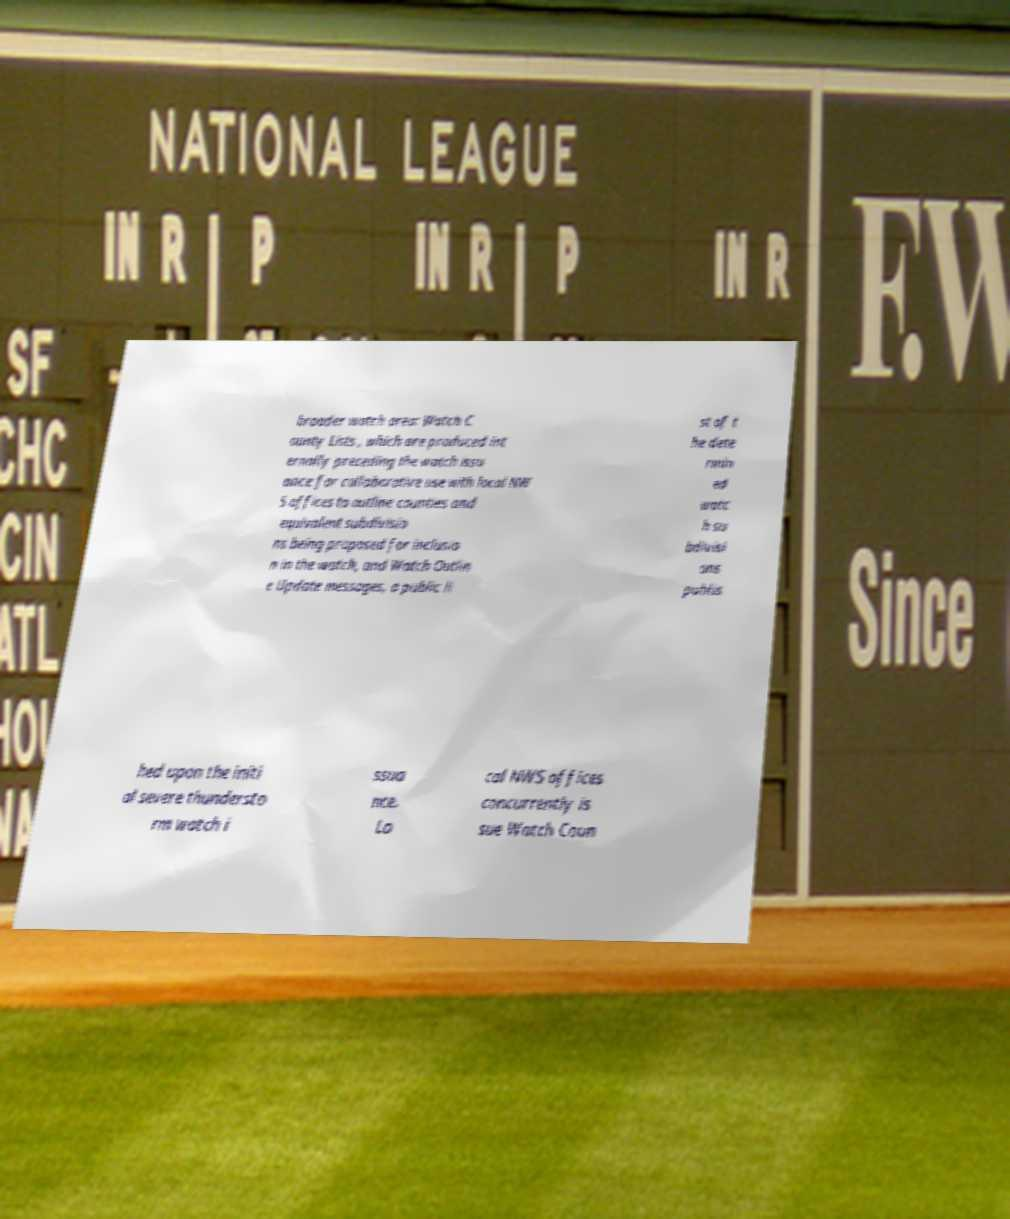There's text embedded in this image that I need extracted. Can you transcribe it verbatim? broader watch area: Watch C ounty Lists , which are produced int ernally preceding the watch issu ance for collaborative use with local NW S offices to outline counties and equivalent subdivisio ns being proposed for inclusio n in the watch, and Watch Outlin e Update messages, a public li st of t he dete rmin ed watc h su bdivisi ons publis hed upon the initi al severe thundersto rm watch i ssua nce. Lo cal NWS offices concurrently is sue Watch Coun 